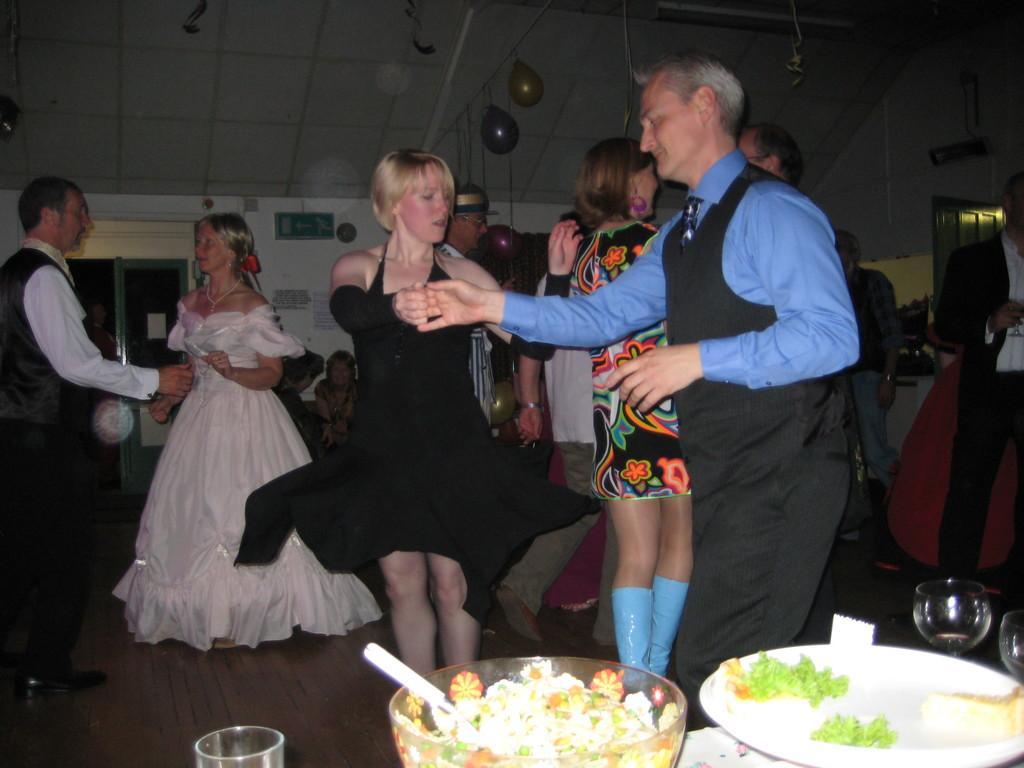Please provide a concise description of this image. In this image we can see people, balloon, signboard, doors, plate, bowl, glasses, food and posters. Posters are on the wall. 